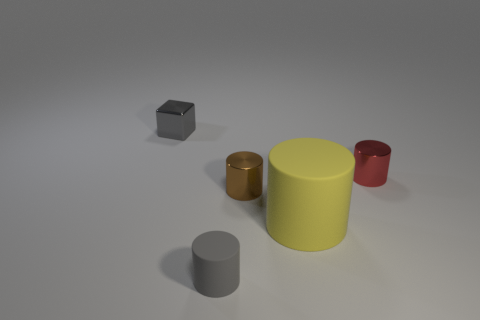Add 3 small gray rubber blocks. How many objects exist? 8 Subtract all large yellow matte cylinders. How many cylinders are left? 3 Subtract all red cylinders. How many cylinders are left? 3 Subtract all blocks. How many objects are left? 4 Subtract 1 cylinders. How many cylinders are left? 3 Add 2 cyan cylinders. How many cyan cylinders exist? 2 Subtract 1 red cylinders. How many objects are left? 4 Subtract all green cylinders. Subtract all gray cubes. How many cylinders are left? 4 Subtract all purple balls. How many brown cylinders are left? 1 Subtract all large brown matte cylinders. Subtract all big yellow matte cylinders. How many objects are left? 4 